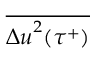<formula> <loc_0><loc_0><loc_500><loc_500>\overline { { { \Delta u } ^ { 2 } ( \tau ^ { + } ) } }</formula> 